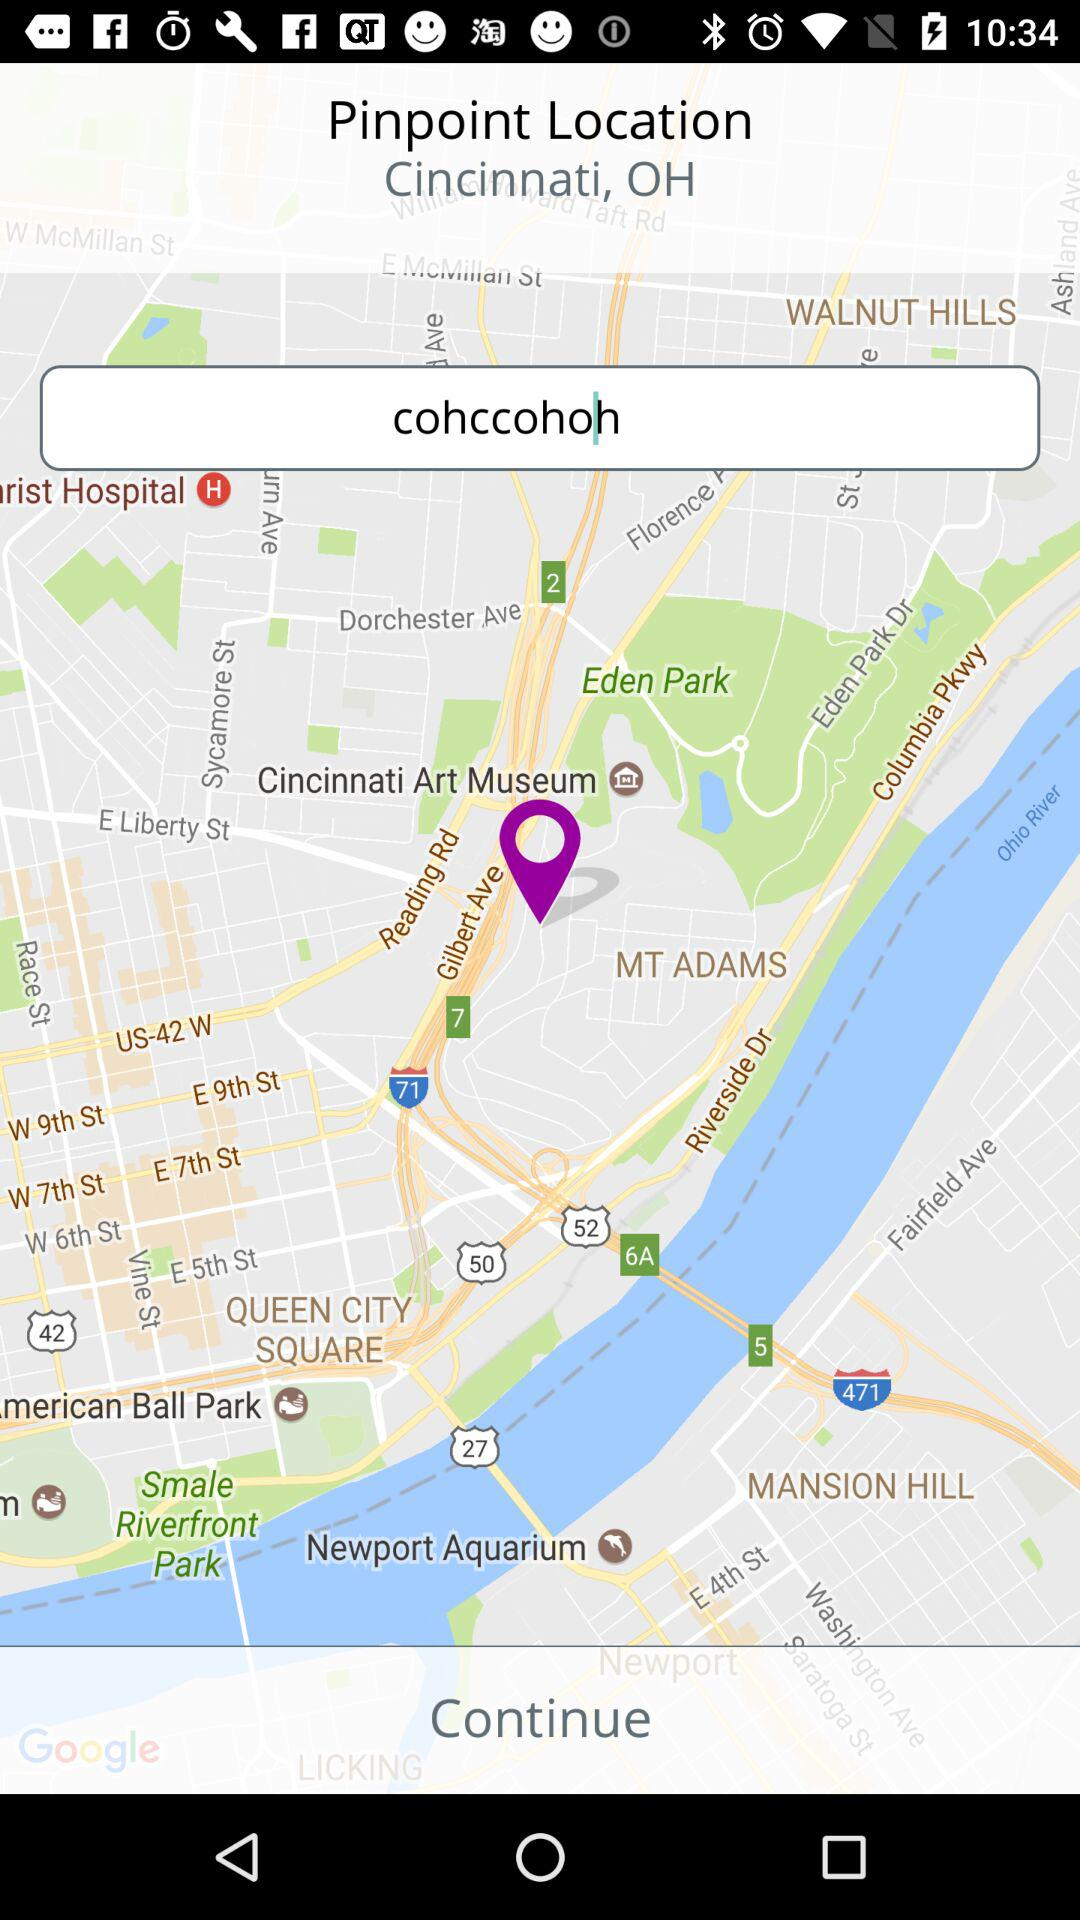What is the location? The location is Cincinnati, OH. 